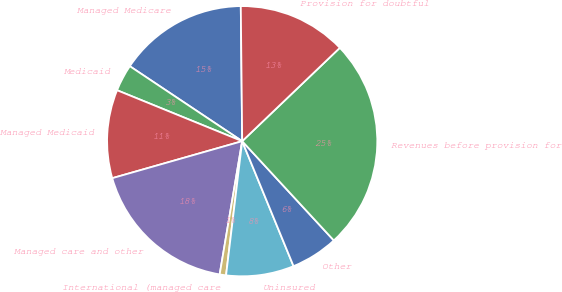Convert chart to OTSL. <chart><loc_0><loc_0><loc_500><loc_500><pie_chart><fcel>Managed Medicare<fcel>Medicaid<fcel>Managed Medicaid<fcel>Managed care and other<fcel>International (managed care<fcel>Uninsured<fcel>Other<fcel>Revenues before provision for<fcel>Provision for doubtful<nl><fcel>15.47%<fcel>3.21%<fcel>10.57%<fcel>17.92%<fcel>0.76%<fcel>8.11%<fcel>5.66%<fcel>25.28%<fcel>13.02%<nl></chart> 